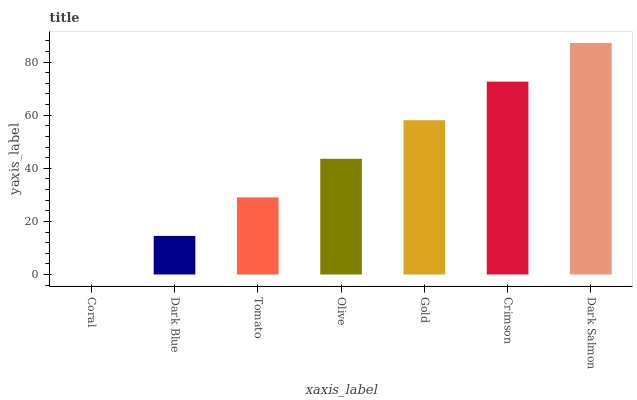Is Coral the minimum?
Answer yes or no. Yes. Is Dark Salmon the maximum?
Answer yes or no. Yes. Is Dark Blue the minimum?
Answer yes or no. No. Is Dark Blue the maximum?
Answer yes or no. No. Is Dark Blue greater than Coral?
Answer yes or no. Yes. Is Coral less than Dark Blue?
Answer yes or no. Yes. Is Coral greater than Dark Blue?
Answer yes or no. No. Is Dark Blue less than Coral?
Answer yes or no. No. Is Olive the high median?
Answer yes or no. Yes. Is Olive the low median?
Answer yes or no. Yes. Is Tomato the high median?
Answer yes or no. No. Is Gold the low median?
Answer yes or no. No. 